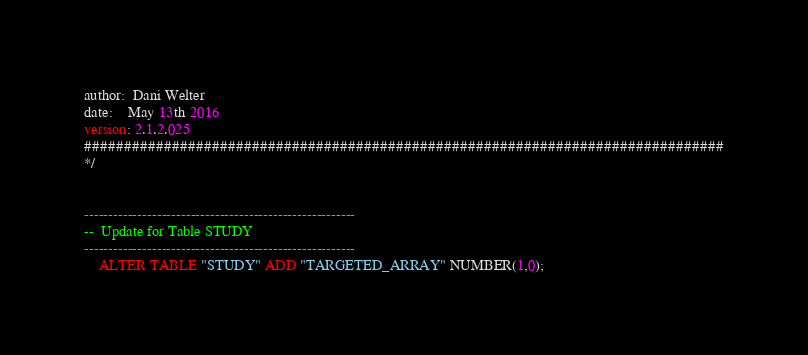<code> <loc_0><loc_0><loc_500><loc_500><_SQL_>
author:  Dani Welter
date:    May 13th 2016
version: 2.1.2.025
################################################################################
*/


--------------------------------------------------------
--  Update for Table STUDY
--------------------------------------------------------
    ALTER TABLE "STUDY" ADD "TARGETED_ARRAY" NUMBER(1,0);</code> 